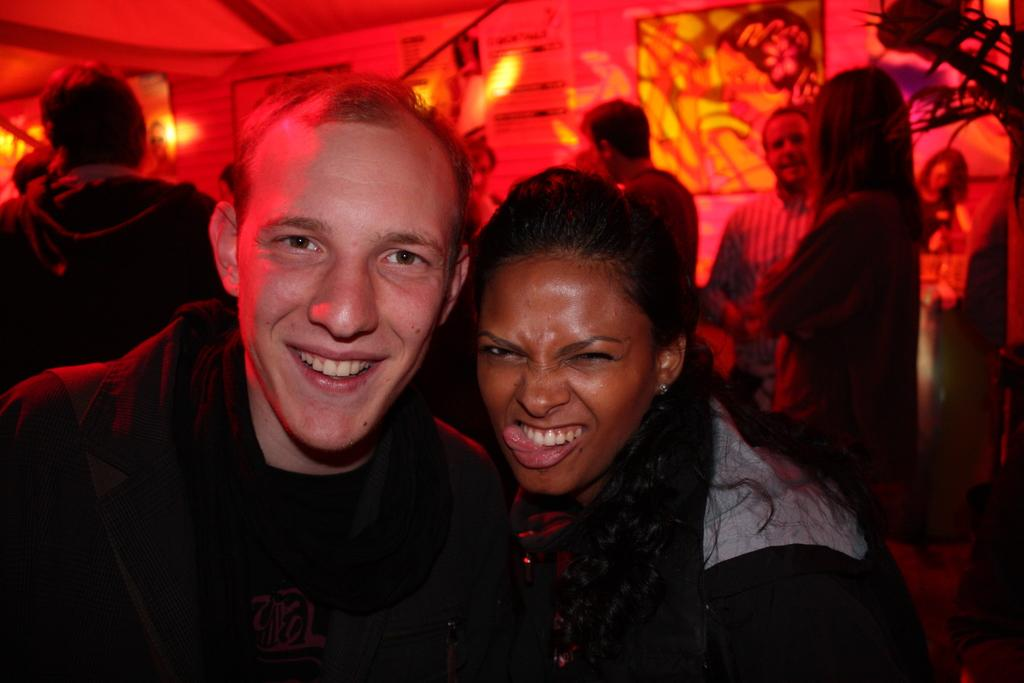What is the main subject of the image? The main subject of the image is a group of people. What are the people wearing in the image? The people are wearing dresses in the image. What can be seen in the background of the image? There are boards and lights in the background of the image. What type of attraction is the group of people visiting in the image? There is no indication of an attraction in the image; it only shows a group of people wearing dresses with boards and lights in the background. 